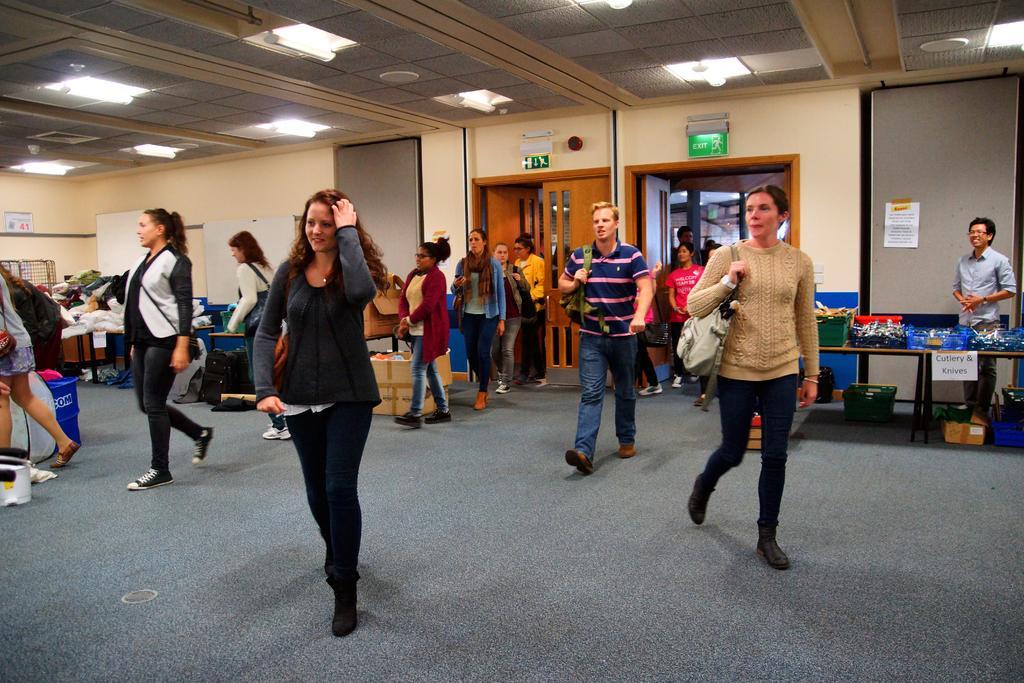How would you summarize this image in a sentence or two? In this image we can see persons standing on the floor. In the background we can see heap of clothes, electric lights, whiteboards, windows, cardboard cartons, plastic baskets, bags, sign boards and doors. 